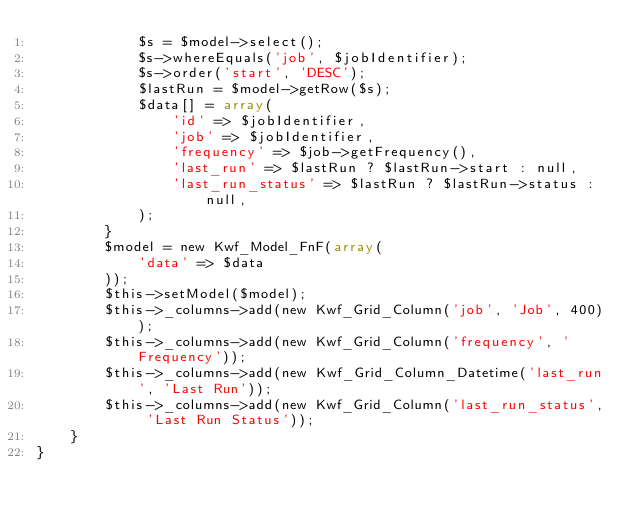Convert code to text. <code><loc_0><loc_0><loc_500><loc_500><_PHP_>            $s = $model->select();
            $s->whereEquals('job', $jobIdentifier);
            $s->order('start', 'DESC');
            $lastRun = $model->getRow($s);
            $data[] = array(
                'id' => $jobIdentifier,
                'job' => $jobIdentifier,
                'frequency' => $job->getFrequency(),
                'last_run' => $lastRun ? $lastRun->start : null,
                'last_run_status' => $lastRun ? $lastRun->status : null,
            );
        }
        $model = new Kwf_Model_FnF(array(
            'data' => $data
        ));
        $this->setModel($model);
        $this->_columns->add(new Kwf_Grid_Column('job', 'Job', 400));
        $this->_columns->add(new Kwf_Grid_Column('frequency', 'Frequency'));
        $this->_columns->add(new Kwf_Grid_Column_Datetime('last_run', 'Last Run'));
        $this->_columns->add(new Kwf_Grid_Column('last_run_status', 'Last Run Status'));
    }
}

</code> 